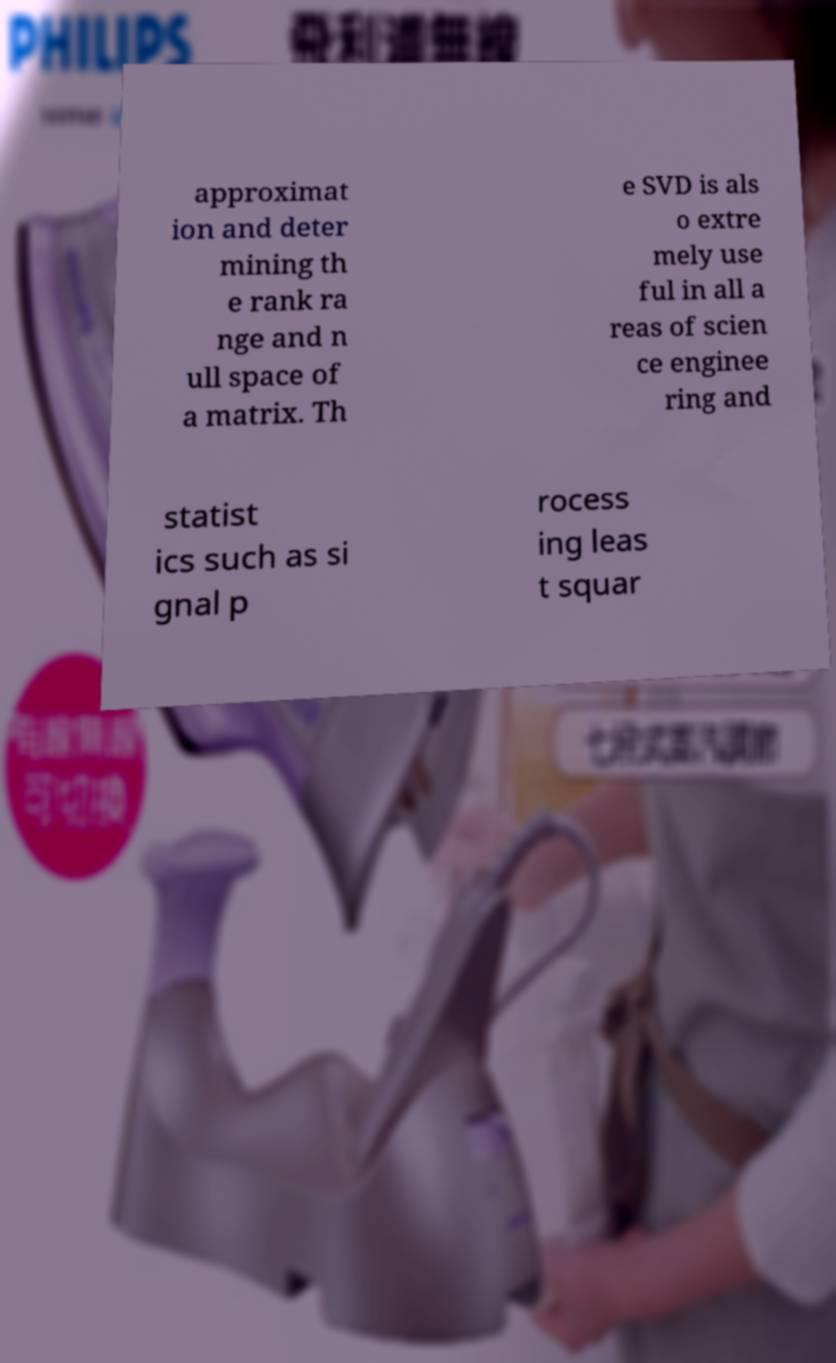For documentation purposes, I need the text within this image transcribed. Could you provide that? approximat ion and deter mining th e rank ra nge and n ull space of a matrix. Th e SVD is als o extre mely use ful in all a reas of scien ce enginee ring and statist ics such as si gnal p rocess ing leas t squar 